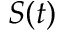<formula> <loc_0><loc_0><loc_500><loc_500>S ( t )</formula> 